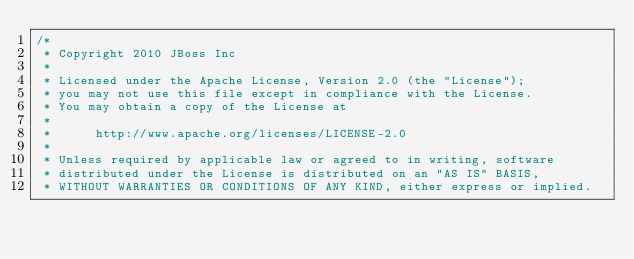Convert code to text. <code><loc_0><loc_0><loc_500><loc_500><_Java_>/*
 * Copyright 2010 JBoss Inc
 *
 * Licensed under the Apache License, Version 2.0 (the "License");
 * you may not use this file except in compliance with the License.
 * You may obtain a copy of the License at
 *
 *      http://www.apache.org/licenses/LICENSE-2.0
 *
 * Unless required by applicable law or agreed to in writing, software
 * distributed under the License is distributed on an "AS IS" BASIS,
 * WITHOUT WARRANTIES OR CONDITIONS OF ANY KIND, either express or implied.</code> 